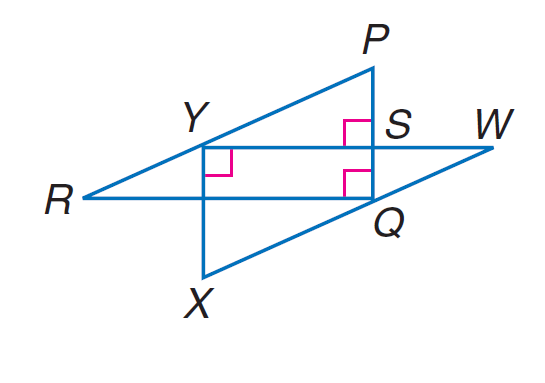Question: If P R \parallel W X, W X = 10, X Y = 6, W Y = 8, R Y = 5, and P S = 3, find S Y.
Choices:
A. 3
B. 4
C. 6
D. 6.5
Answer with the letter. Answer: B Question: If P R \parallel W X, W X = 10, X Y = 6, W Y = 8, R Y = 5, and P S = 3, find P Q.
Choices:
A. 5.5
B. 6
C. 8
D. 11
Answer with the letter. Answer: B 